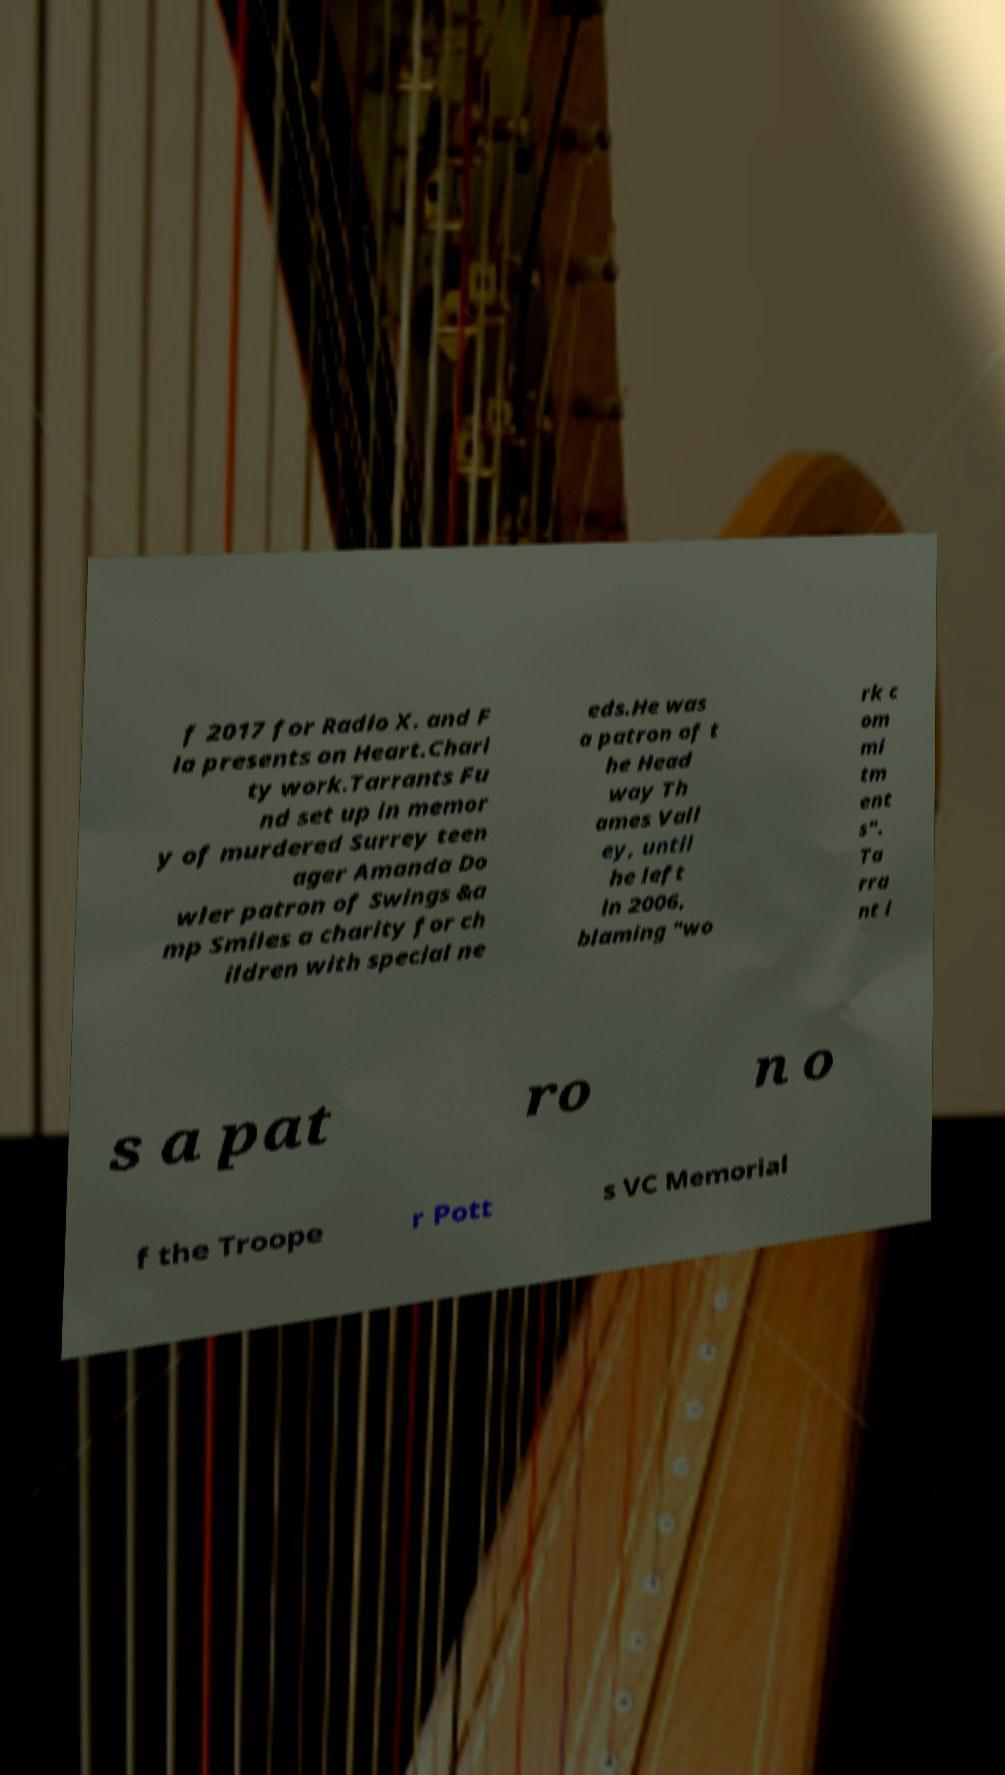There's text embedded in this image that I need extracted. Can you transcribe it verbatim? f 2017 for Radio X. and F ia presents on Heart.Chari ty work.Tarrants Fu nd set up in memor y of murdered Surrey teen ager Amanda Do wler patron of Swings &a mp Smiles a charity for ch ildren with special ne eds.He was a patron of t he Head way Th ames Vall ey, until he left in 2006, blaming "wo rk c om mi tm ent s". Ta rra nt i s a pat ro n o f the Troope r Pott s VC Memorial 